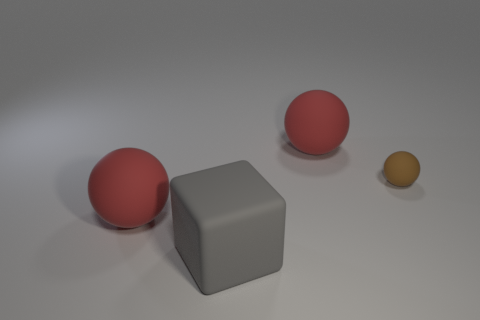Add 3 large red objects. How many objects exist? 7 Subtract all blocks. How many objects are left? 3 Add 2 large purple balls. How many large purple balls exist? 2 Subtract 0 cyan blocks. How many objects are left? 4 Subtract all big yellow metal cylinders. Subtract all small rubber things. How many objects are left? 3 Add 2 red balls. How many red balls are left? 4 